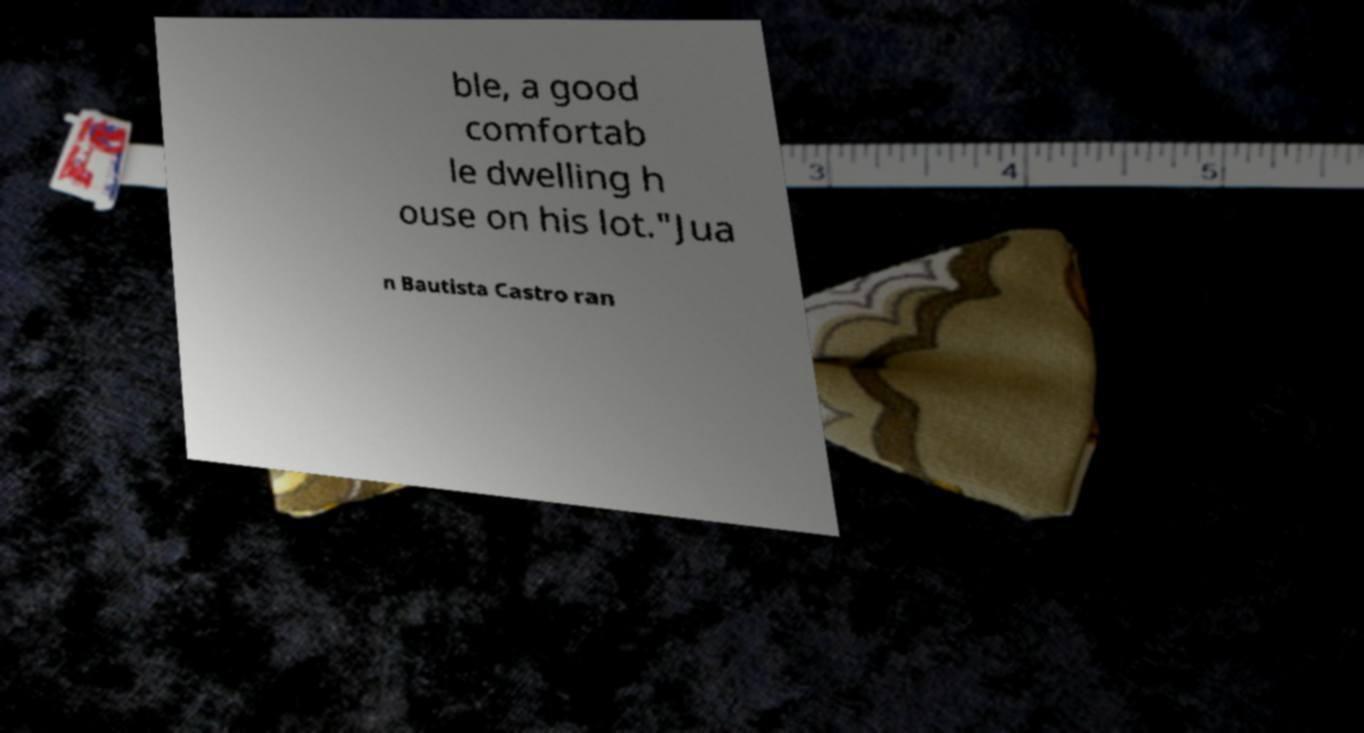What messages or text are displayed in this image? I need them in a readable, typed format. ble, a good comfortab le dwelling h ouse on his lot."Jua n Bautista Castro ran 